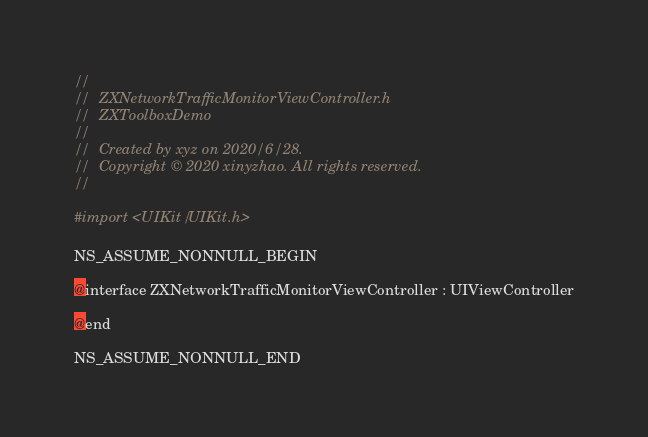<code> <loc_0><loc_0><loc_500><loc_500><_C_>//
//  ZXNetworkTrafficMonitorViewController.h
//  ZXToolboxDemo
//
//  Created by xyz on 2020/6/28.
//  Copyright © 2020 xinyzhao. All rights reserved.
//

#import <UIKit/UIKit.h>

NS_ASSUME_NONNULL_BEGIN

@interface ZXNetworkTrafficMonitorViewController : UIViewController

@end

NS_ASSUME_NONNULL_END
</code> 